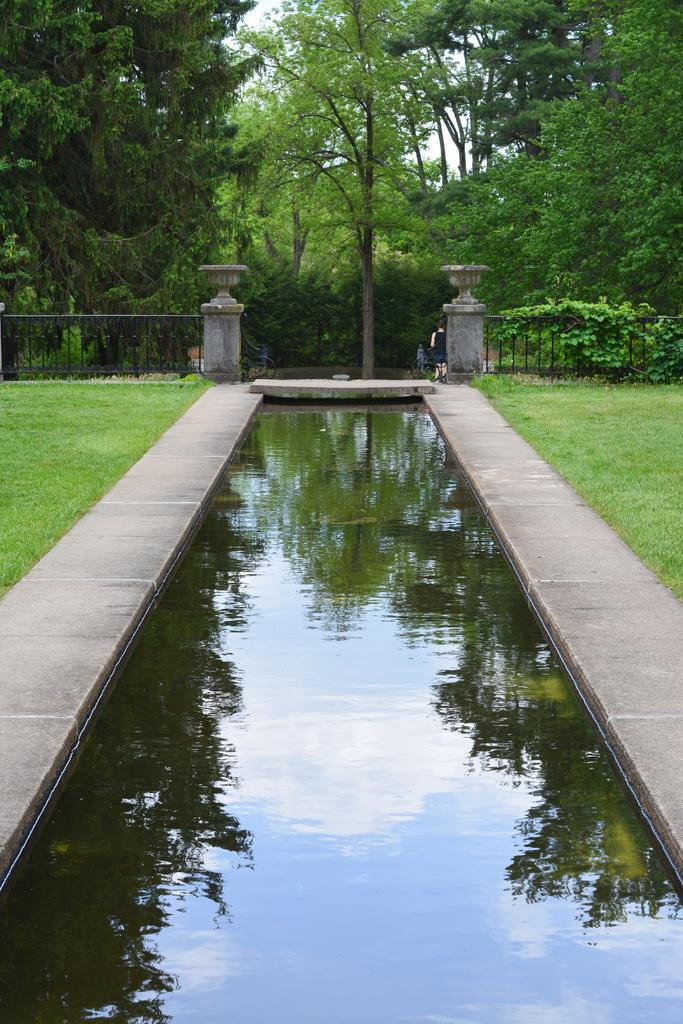What is in the front of the image? There is water in the front of the image. What type of vegetation is on the ground? There is grass on the ground. What can be seen in the center of the image? There is a fence in the center of the image. What is visible elements are in the background of the image? There are trees in the background of the image. What type of joke is being told by the trees in the background of the image? There is no indication in the image that the trees are telling a joke; they are simply visible in the background. How far away is the lunch from the water in the front of the image? There is no lunch present in the image, so it cannot be determined how far away it might be from the water. 